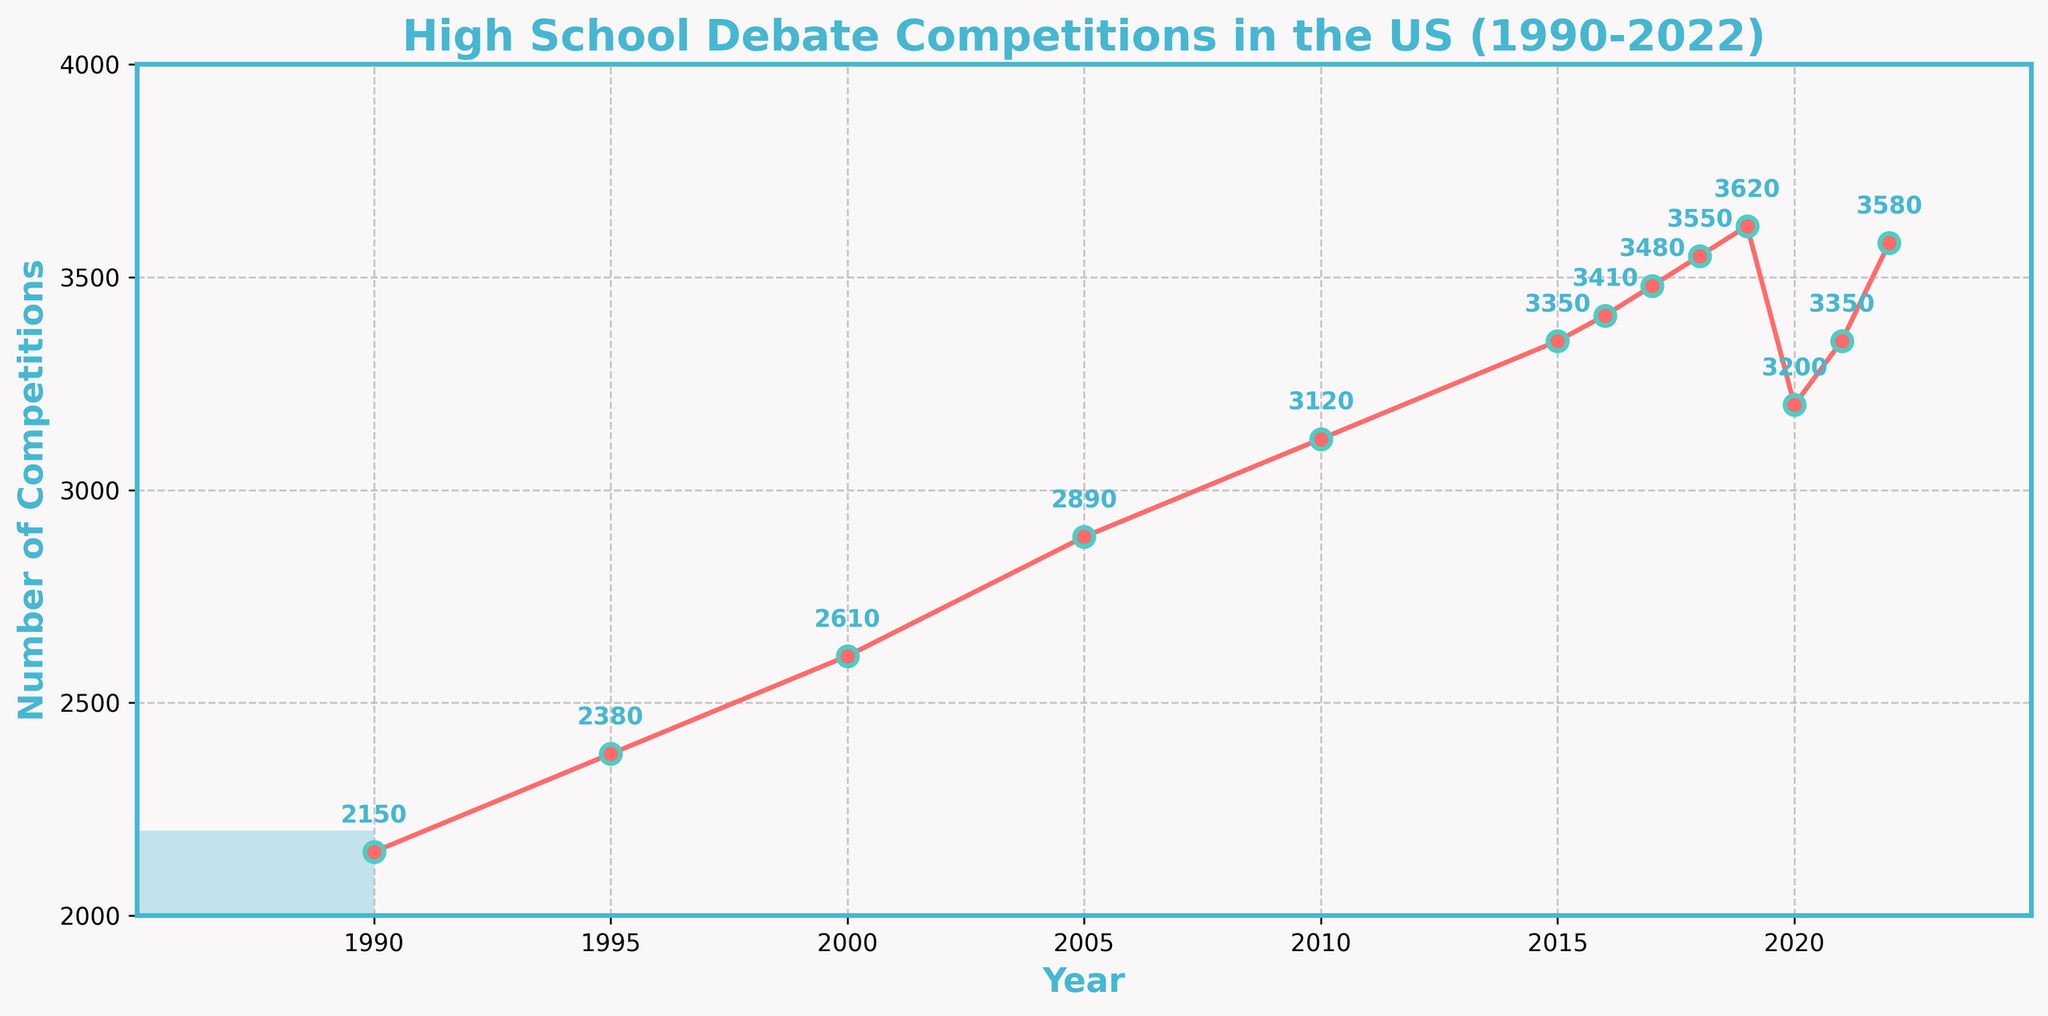What trend can be observed in the number of high school debate competitions held annually from 1990 to 2022? The number of high school debate competitions generally increased from 1990 to 2019, then experienced a drop in 2020, possibly due to the COVID-19 pandemic. It then started to recover again in 2021 and 2022.
Answer: Increasing trend with a dip in 2020 How many high school debate competitions were held in 2010, and how does this number compare to 2020? In 2010, 3120 competitions were held, while in 2020 there were 3200 competitions. To compare, 3120 is less than 3200.
Answer: 3120 is less than 3200 What is the highest number of high school debate competitions held in any given year between 1990 and 2022? The highest number of competitions held is found by looking for the peak value on the plot. According to the chart, the maximum number of competitions was held in 2022 with 3580 competitions.
Answer: 3580 Calculate the average number of high school debate competitions per year from 1990 to 2000. Adding the numbers from 1990 (2150), 1995 (2380), and 2000 (2610) gives a total of 7140 competitions over 3 data points. To find the average: 7140 / 3.
Answer: 2380 Which year saw the smallest increase in the number of high school debate competitions compared to the previous year? By looking at the differences each year, the smallest increase happens between 2015 (3350) and 2016 (3410), as the increase is just 60 (3410 - 3350).
Answer: 2016 How does the number of competitions in 2021 compare to the number in 2019? The number of competitions in 2019 was 3620 and in 2021 it was 3350. To compare, 3350 is less than 3620.
Answer: 3350 is less than 3620 What was the overall percentage increase in the number of debate competitions from 1990 to 2019? The initial number of competitions in 1990 was 2150, the increase to 3620 in 2019 is 3620 - 2150 = 1470. The percentage increase is (1470 / 2150) * 100.
Answer: 68.37% Which years show consecutive increases in the number of high school debate competitions? By observing the plot, the years showing consecutive increases are from 1990 to 2019, except for the dip in 2020 following the peak in 2019. After 2020, there were consecutive increases again in 2021 and 2022.
Answer: 1990-2019 (except 2020), 2021-2022 